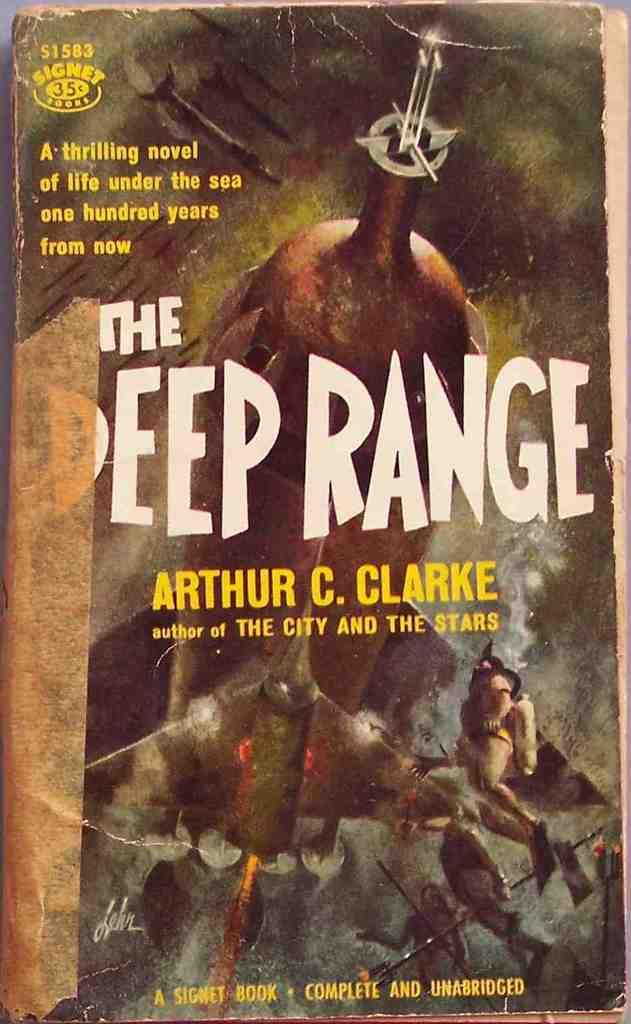What is the main subject in the center of the image? There is a poster in the center of the image. What can be found on the poster? The poster contains text and other objects. What type of picture is displayed on the poster? There is no picture displayed on the poster; it contains text and other objects. How can we tell if the event mentioned on the poster is quiet or noisy? The image does not provide any information about the event's noise level, as it only shows the poster itself. 